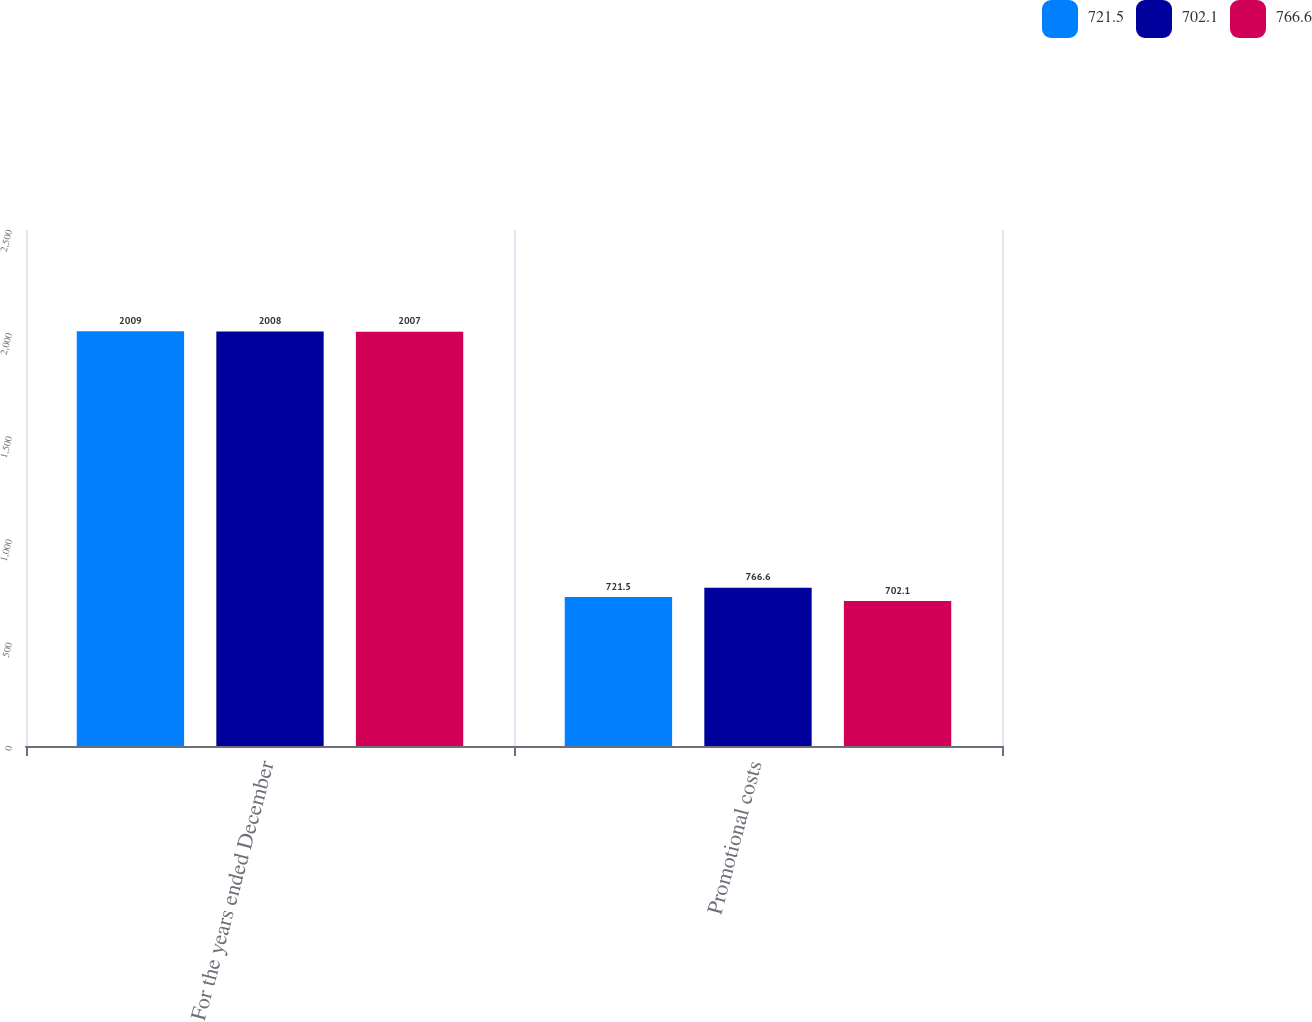Convert chart. <chart><loc_0><loc_0><loc_500><loc_500><stacked_bar_chart><ecel><fcel>For the years ended December<fcel>Promotional costs<nl><fcel>721.5<fcel>2009<fcel>721.5<nl><fcel>702.1<fcel>2008<fcel>766.6<nl><fcel>766.6<fcel>2007<fcel>702.1<nl></chart> 